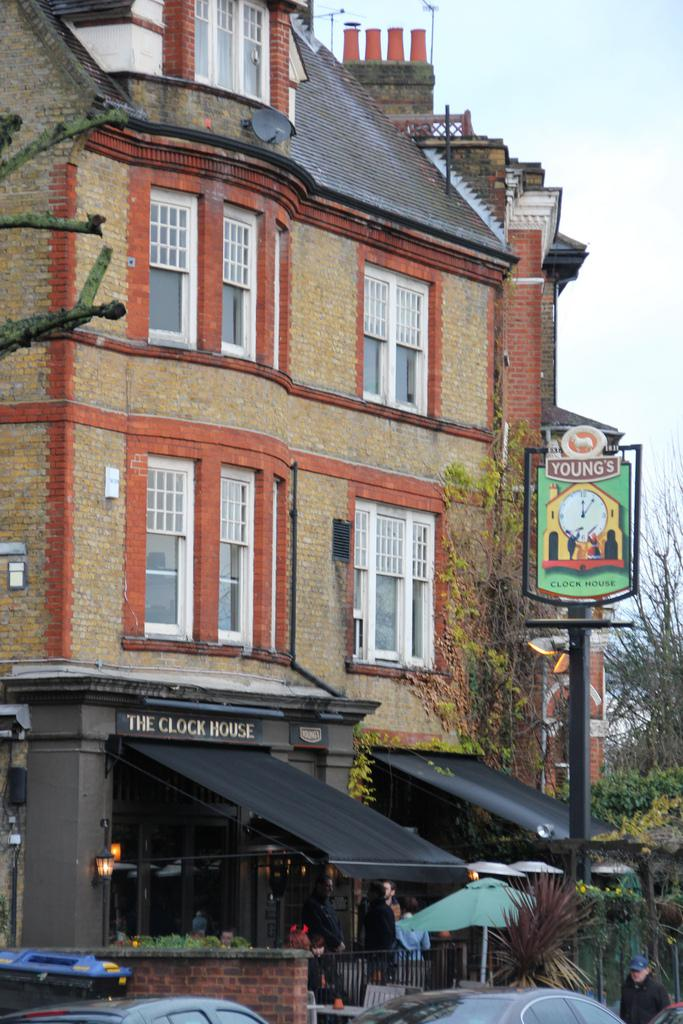Question: what does the sign say?
Choices:
A. Tall.
B. Olds.
C. Free.
D. Youngs.
Answer with the letter. Answer: D Question: how many umbrellas are there?
Choices:
A. Two umbrellas.
B. One umbrella.
C. Three umbrellas.
D. Four Umbrellas.
Answer with the letter. Answer: B Question: how many cars are there?
Choices:
A. Three Cars.
B. One Car.
C. Four Cars.
D. Two cars.
Answer with the letter. Answer: D Question: where was the picture taken?
Choices:
A. In the street.
B. At a bar.
C. At a bus stop.
D. At a house.
Answer with the letter. Answer: A Question: what colors are the awnings?
Choices:
A. White.
B. Blue.
C. Yellow.
D. Black.
Answer with the letter. Answer: D Question: what is the name of the building?
Choices:
A. Hospital.
B. Church.
C. Farm house.
D. Clock house.
Answer with the letter. Answer: D Question: how many chimney pots are there?
Choices:
A. Three.
B. Four.
C. Two.
D. None.
Answer with the letter. Answer: B Question: what color are the windows?
Choices:
A. Black.
B. Yellow.
C. Blue.
D. White.
Answer with the letter. Answer: D Question: what time is on the clock?
Choices:
A. 11:05.
B. 1:05.
C. 12:25.
D. 12:05.
Answer with the letter. Answer: D Question: where was this photo taken?
Choices:
A. Outside of Young's.
B. In the park.
C. At the airport.
D. In the house.
Answer with the letter. Answer: A Question: how many cars are parked in front of the clock house?
Choices:
A. One.
B. Two.
C. Three.
D. Four.
Answer with the letter. Answer: C Question: how many men are in front of the brick building?
Choices:
A. One.
B. Two.
C. Three.
D. Four.
Answer with the letter. Answer: C Question: what is trimmed in brick?
Choices:
A. Windows and edges of the building.
B. Flower beds.
C. Sidewalks.
D. Driveways.
Answer with the letter. Answer: A Question: what is pale?
Choices:
A. The river.
B. The lake.
C. The ocean.
D. Sky.
Answer with the letter. Answer: D Question: where are cars parked?
Choices:
A. In a parking lot.
B. In garages.
C. By the lakeside.
D. On the street.
Answer with the letter. Answer: D Question: what does the business say on it?
Choices:
A. The motel.
B. The Clock House.
C. The mall.
D. The Pharmacy.
Answer with the letter. Answer: B Question: what is on the side of the building?
Choices:
A. Plants.
B. Grass.
C. Leaves.
D. Bricks.
Answer with the letter. Answer: C 